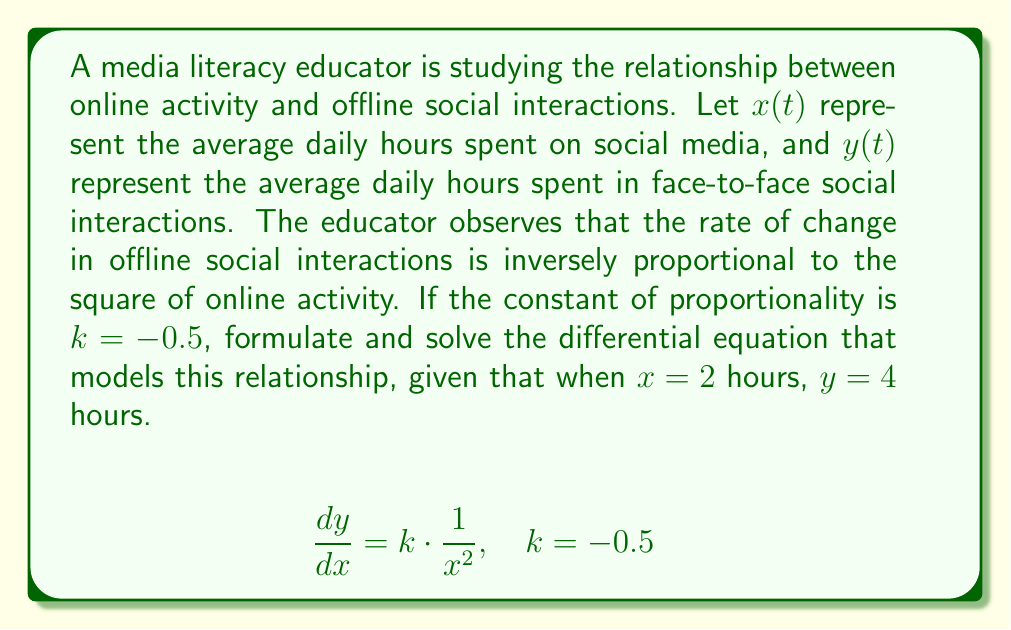Can you answer this question? 1) First, we formulate the differential equation based on the given information:
   $$\frac{dy}{dx} = -\frac{k}{x^2}$$
   
   Where $k = 0.5$ (we use positive 0.5 here as the negative sign is already in the equation)

2) Substitute the value of $k$:
   $$\frac{dy}{dx} = -\frac{0.5}{x^2}$$

3) To solve this, we integrate both sides:
   $$\int dy = -0.5 \int \frac{1}{x^2} dx$$

4) Integrate:
   $$y = 0.5 \frac{1}{x} + C$$

5) Now we use the given condition to find $C$:
   When $x = 2$, $y = 4$
   
   $$4 = 0.5 \frac{1}{2} + C$$
   $$4 = 0.25 + C$$
   $$C = 3.75$$

6) Therefore, the final solution is:
   $$y = 0.5 \frac{1}{x} + 3.75$$

This equation models how offline social interactions ($y$) change as a function of online activity ($x$).
Answer: $y = 0.5 \frac{1}{x} + 3.75$ 